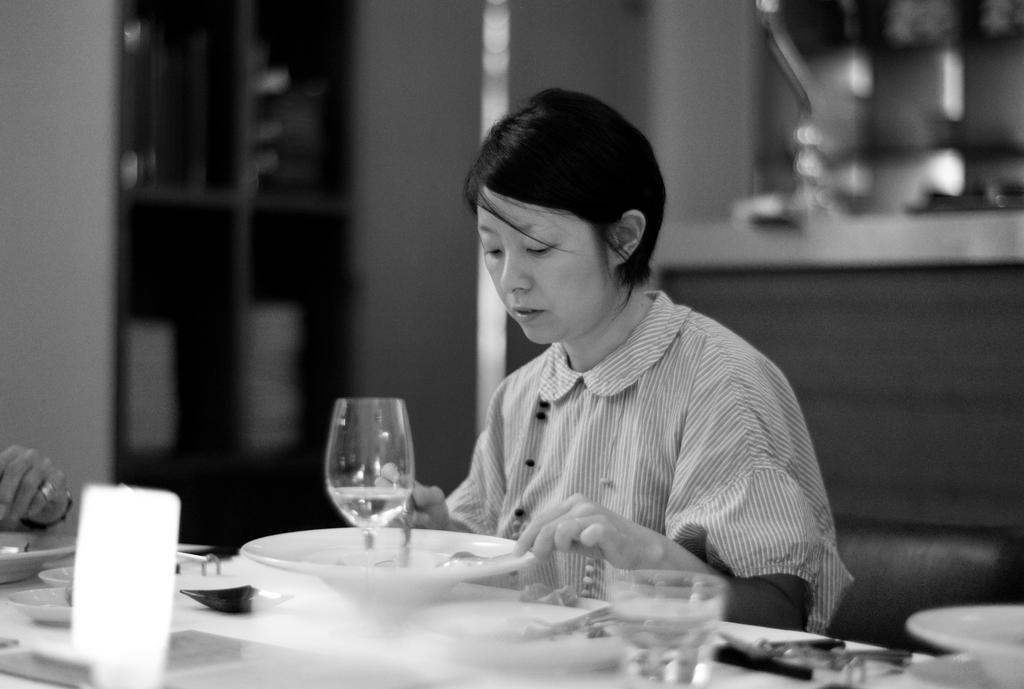Who is the main subject in the image? There is a woman in the image. What is the woman holding in the image? The woman is holding spoons. What else can be seen in the image besides the woman? There is a plate and glasses in the image. What type of root can be seen growing in the field in the image? There is no field or root present in the image; it features a woman holding spoons and a plate with glasses nearby. 